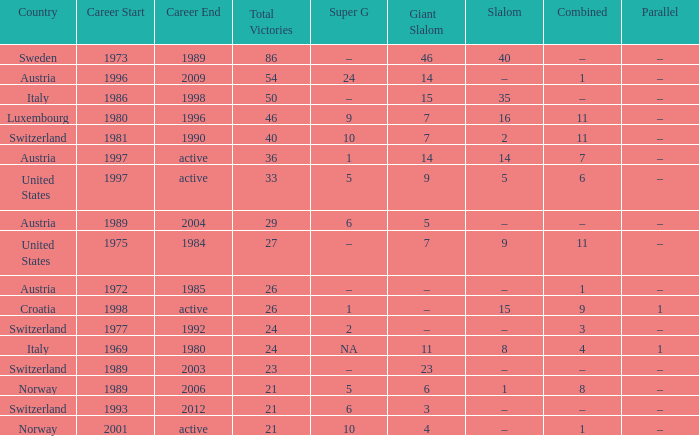What giant slalom boasts wins exceeding 27, a slalom of –, and a career covering 1996–2009? 14.0. 